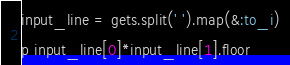Convert code to text. <code><loc_0><loc_0><loc_500><loc_500><_Ruby_>input_line = gets.split(' ').map(&:to_i)

p input_line[0]*input_line[1].floor</code> 